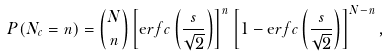<formula> <loc_0><loc_0><loc_500><loc_500>P ( N _ { c } = n ) = \binom { N } { n } \left [ { \mathrm e r f c } \left ( \frac { s } { \sqrt { 2 } } \right ) \right ] ^ { n } \left [ 1 - { \mathrm e r f c } \left ( \frac { s } { \sqrt { 2 } } \right ) \right ] ^ { N - n } ,</formula> 